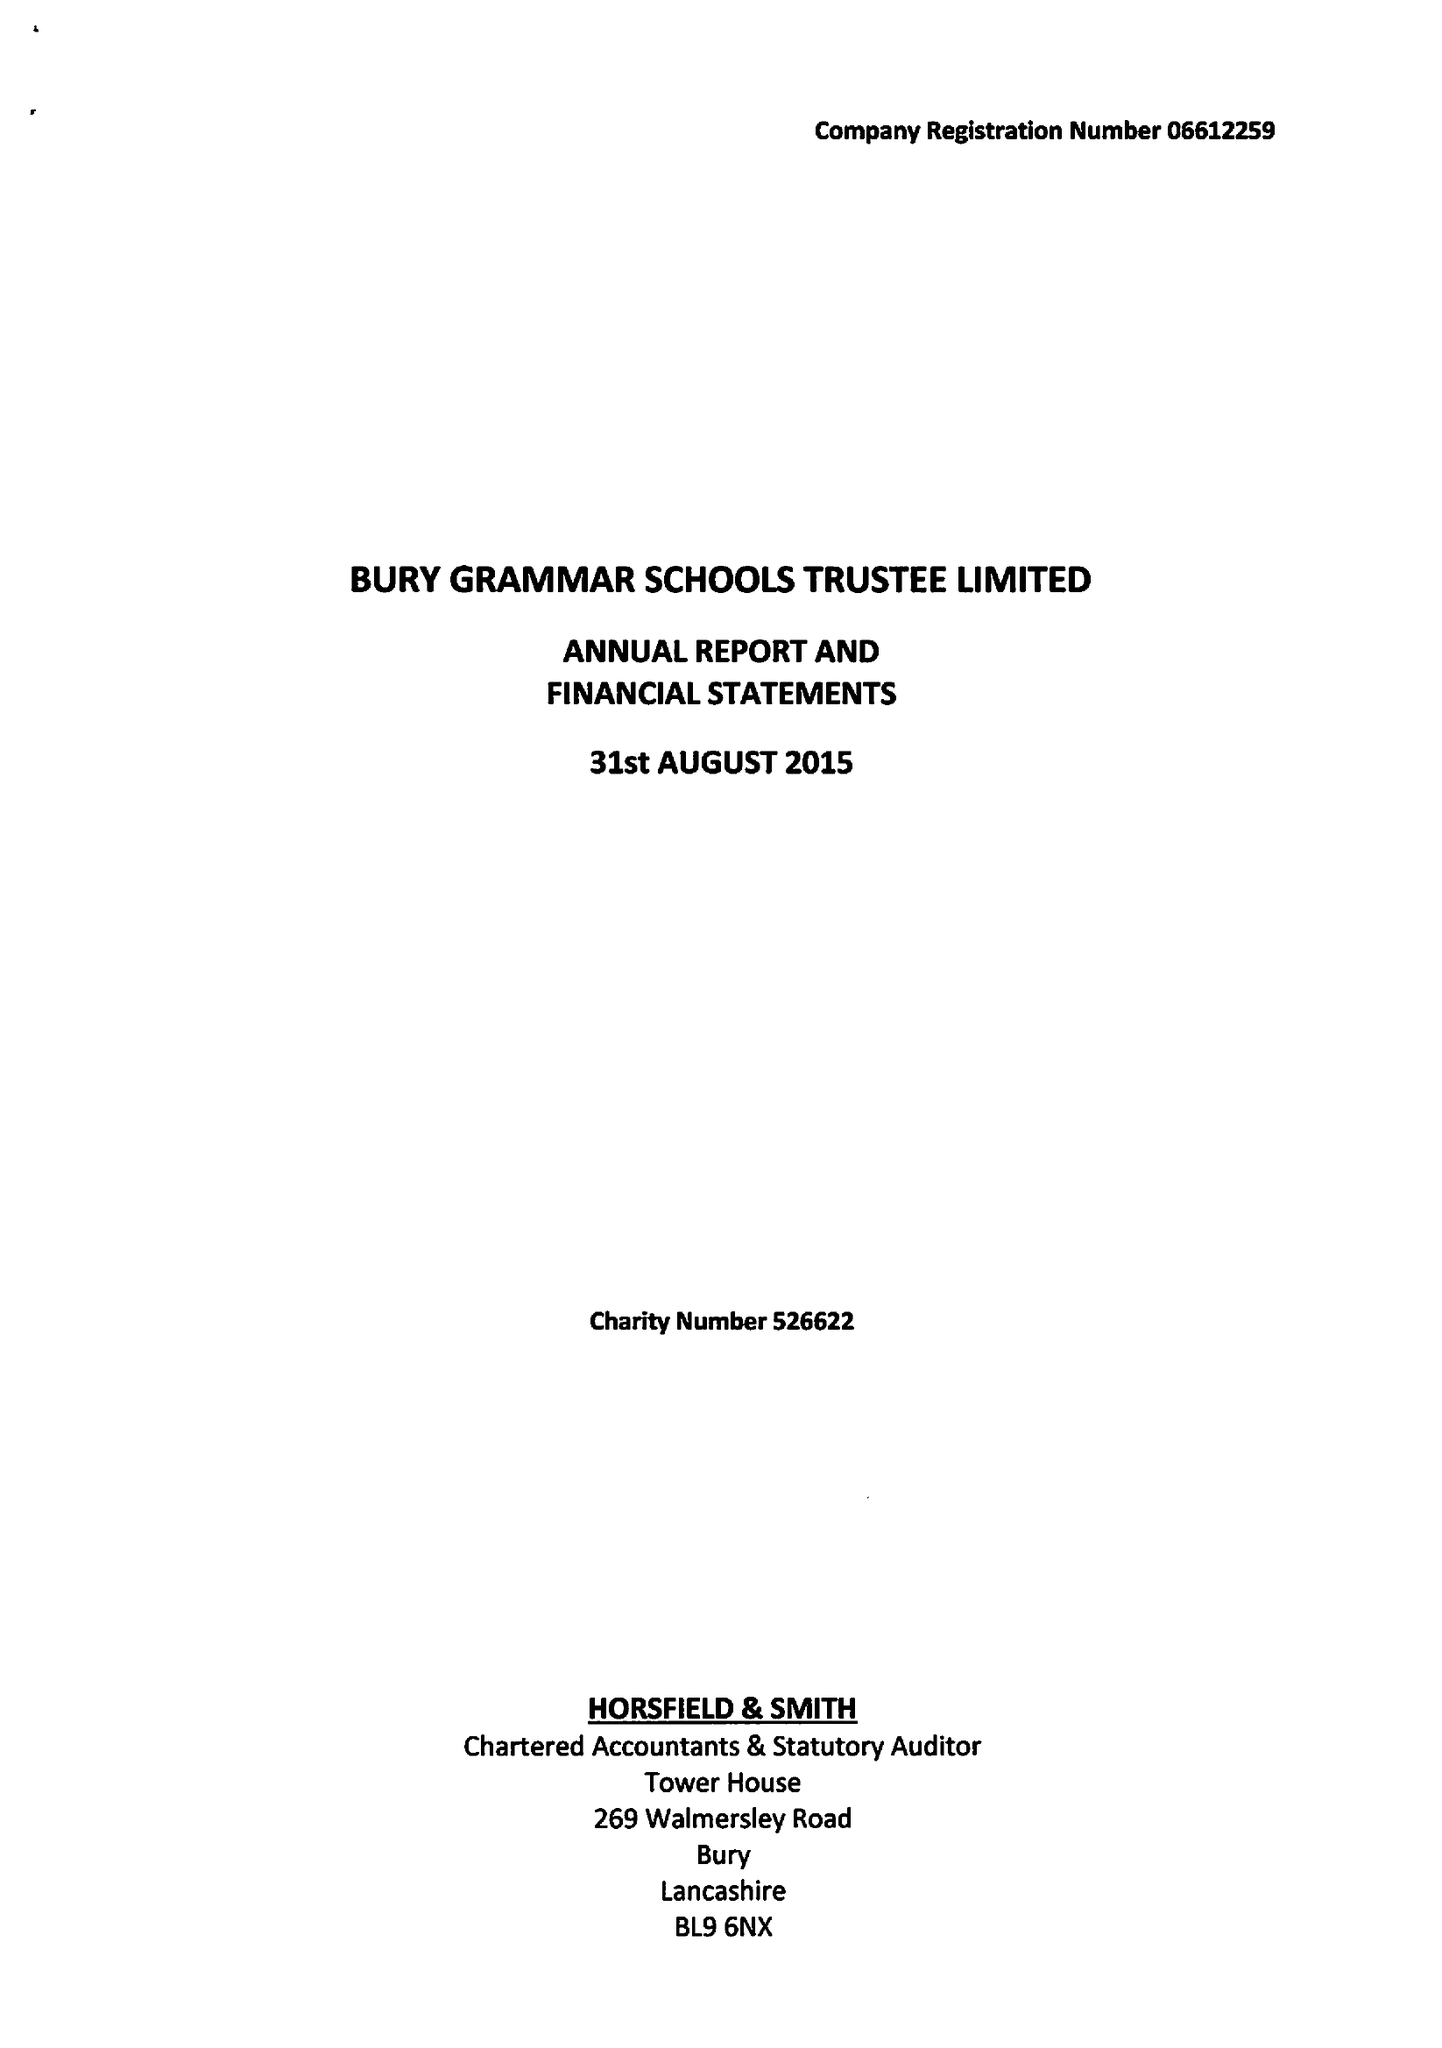What is the value for the spending_annually_in_british_pounds?
Answer the question using a single word or phrase. 12242000.00 